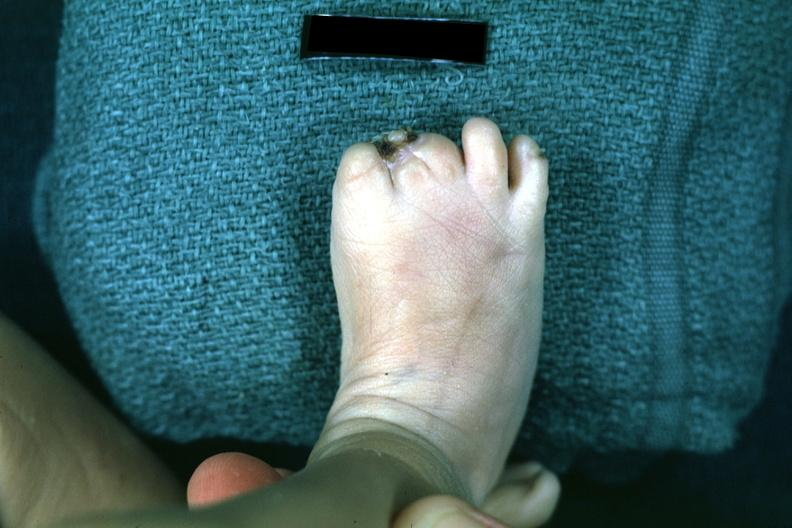what are present?
Answer the question using a single word or phrase. Extremities 